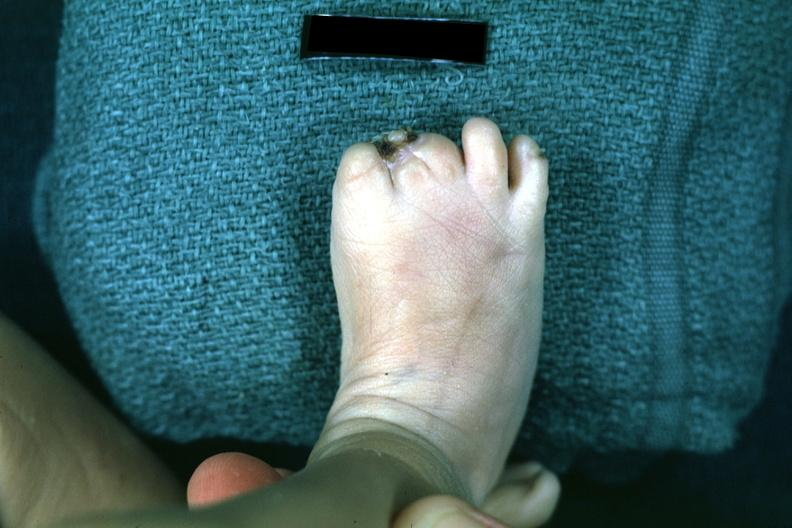what are present?
Answer the question using a single word or phrase. Extremities 